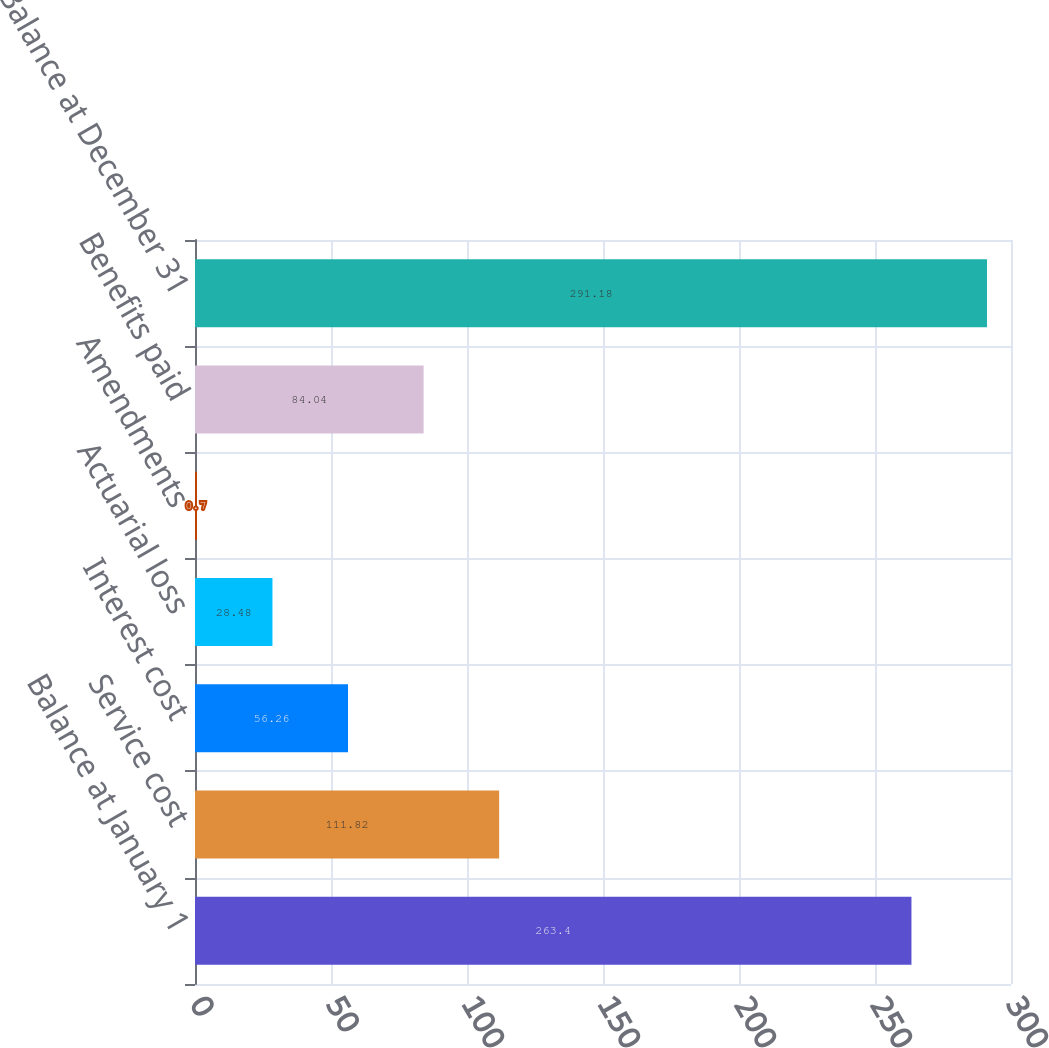Convert chart. <chart><loc_0><loc_0><loc_500><loc_500><bar_chart><fcel>Balance at January 1<fcel>Service cost<fcel>Interest cost<fcel>Actuarial loss<fcel>Amendments<fcel>Benefits paid<fcel>Balance at December 31<nl><fcel>263.4<fcel>111.82<fcel>56.26<fcel>28.48<fcel>0.7<fcel>84.04<fcel>291.18<nl></chart> 